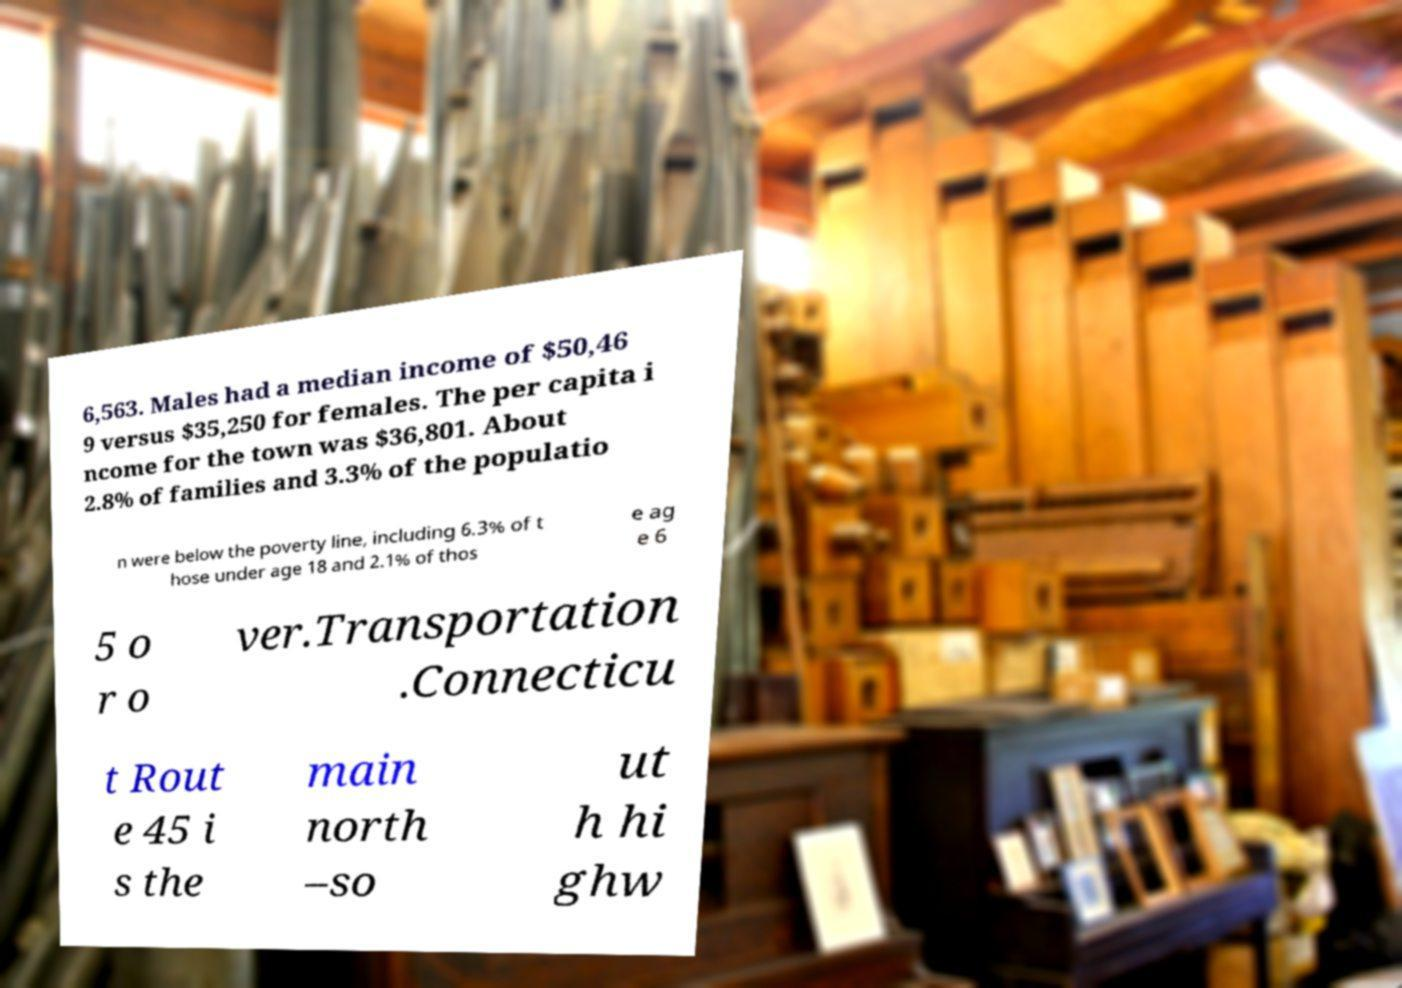What messages or text are displayed in this image? I need them in a readable, typed format. 6,563. Males had a median income of $50,46 9 versus $35,250 for females. The per capita i ncome for the town was $36,801. About 2.8% of families and 3.3% of the populatio n were below the poverty line, including 6.3% of t hose under age 18 and 2.1% of thos e ag e 6 5 o r o ver.Transportation .Connecticu t Rout e 45 i s the main north –so ut h hi ghw 